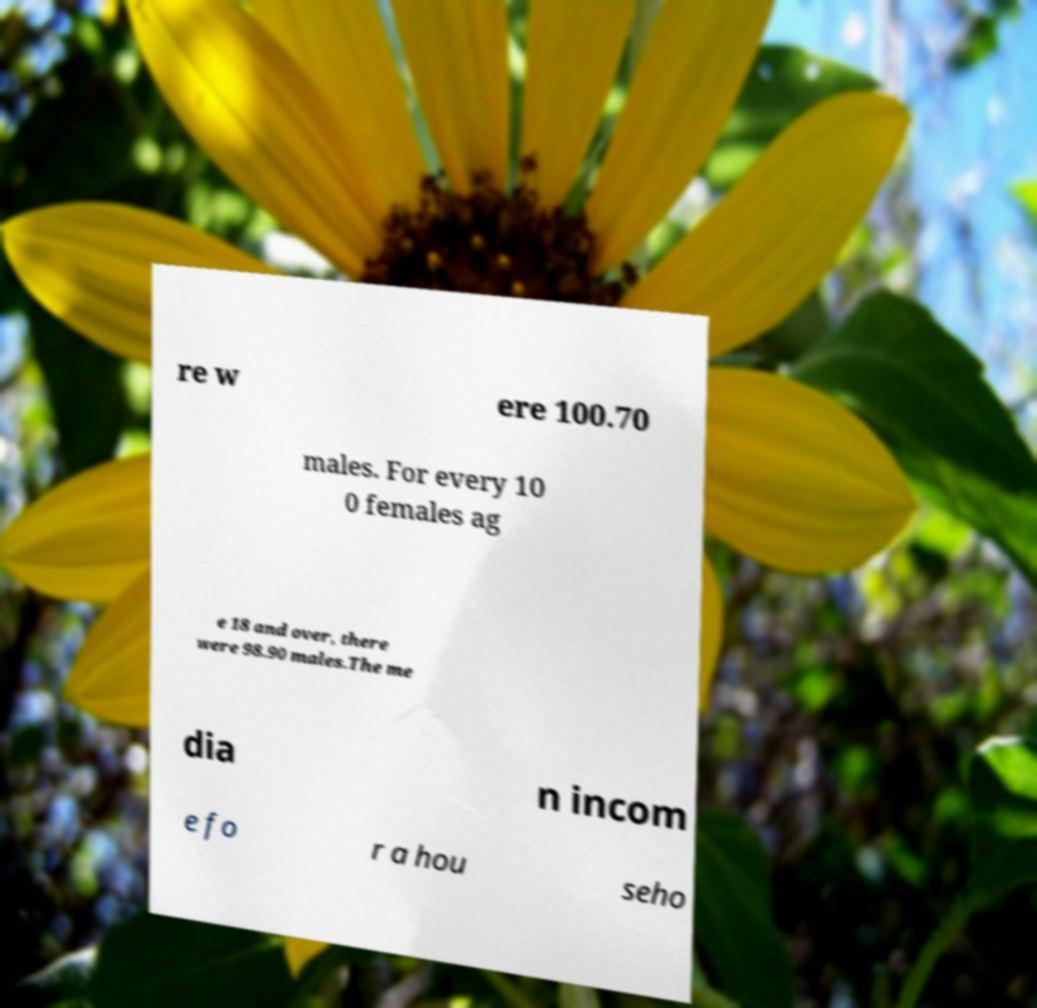I need the written content from this picture converted into text. Can you do that? re w ere 100.70 males. For every 10 0 females ag e 18 and over, there were 98.90 males.The me dia n incom e fo r a hou seho 